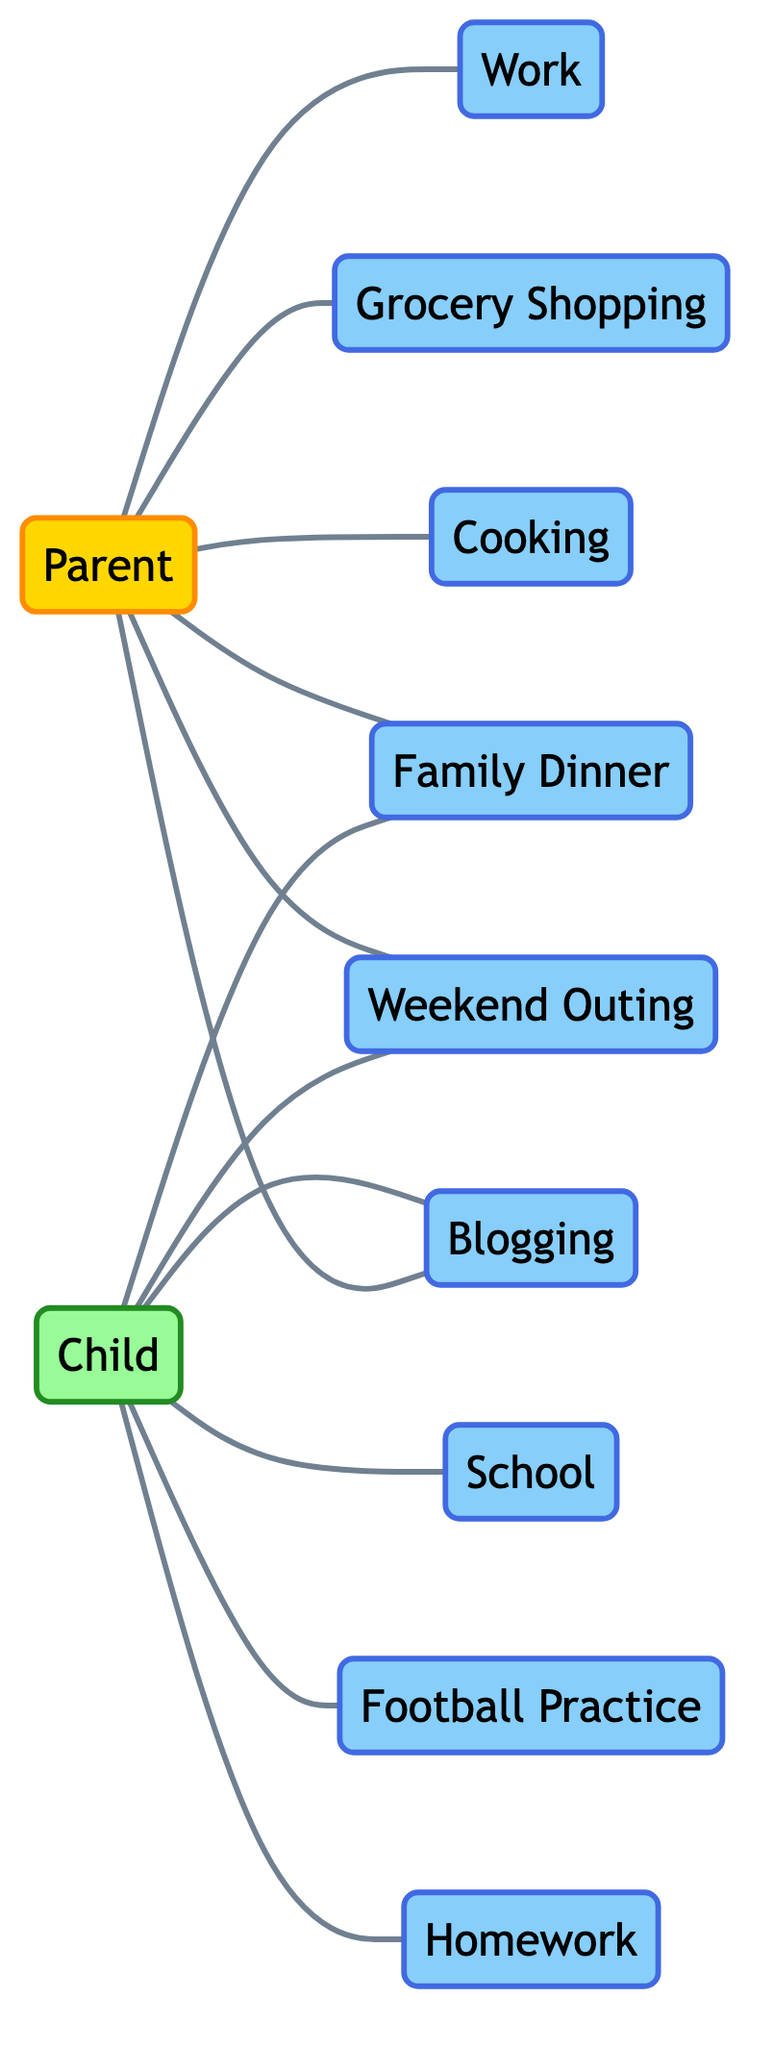What activities is the Parent involved in? The Parent has direct connections to the nodes: Work, Grocery Shopping, Cooking, Family Dinner, Weekend Outing, and Blogging. These nodes represent the activities they are engaged in.
Answer: Work, Grocery Shopping, Cooking, Family Dinner, Weekend Outing, Blogging How many edges are there in total? The edges represent the connections between nodes. Counting them gives a total of 11 edges in the diagram, highlighting the various interactions.
Answer: 11 Who is involved in Blogging? The diagram shows both the Parent and the Child directly connected to the Blogging node, indicating both are engaged in this activity.
Answer: Parent, Child What is the relationship between the Child and Homework? There is a direct connection between the Child and the Homework node, indicating that the Child is involved in this activity.
Answer: Child How many activities involve the Child? The Child is connected to the nodes: School, Football Practice, Family Dinner, Weekend Outing, Blogging, and Homework, indicating a total of 6 activities.
Answer: 6 Which activity is connected to both the Parent and the Child? The Family Dinner node has connections to both the Parent and the Child, showing that this activity involves all family members.
Answer: Family Dinner What is one of the activities the Parent does outside of Family time? The Parent has a connection to the Work node, indicating that this is an activity undertaken outside of direct family time.
Answer: Work Is there a shared activity between the Parent and the Child? Yes, both are connected to the Family Dinner node, indicating it is a shared activity for the family.
Answer: Family Dinner Which node has the least connections? The node "Football Practice" is only connected to the Child, making it the node with the least connections.
Answer: Football Practice 